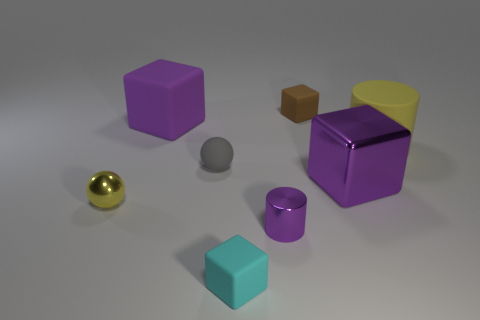Add 1 large blue things. How many objects exist? 9 Subtract all cylinders. How many objects are left? 6 Subtract all yellow spheres. Subtract all tiny gray spheres. How many objects are left? 6 Add 7 tiny purple cylinders. How many tiny purple cylinders are left? 8 Add 8 purple cylinders. How many purple cylinders exist? 9 Subtract 0 green blocks. How many objects are left? 8 